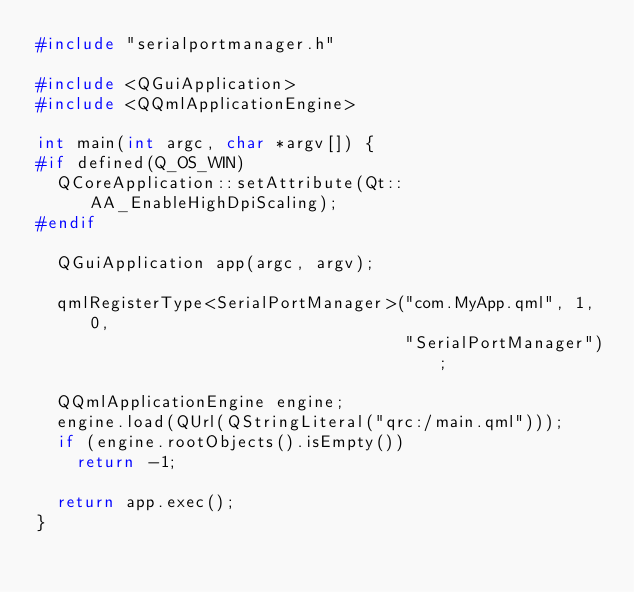Convert code to text. <code><loc_0><loc_0><loc_500><loc_500><_C++_>#include "serialportmanager.h"

#include <QGuiApplication>
#include <QQmlApplicationEngine>

int main(int argc, char *argv[]) {
#if defined(Q_OS_WIN)
  QCoreApplication::setAttribute(Qt::AA_EnableHighDpiScaling);
#endif

  QGuiApplication app(argc, argv);

  qmlRegisterType<SerialPortManager>("com.MyApp.qml", 1, 0,
                                     "SerialPortManager");

  QQmlApplicationEngine engine;
  engine.load(QUrl(QStringLiteral("qrc:/main.qml")));
  if (engine.rootObjects().isEmpty())
    return -1;

  return app.exec();
}
</code> 